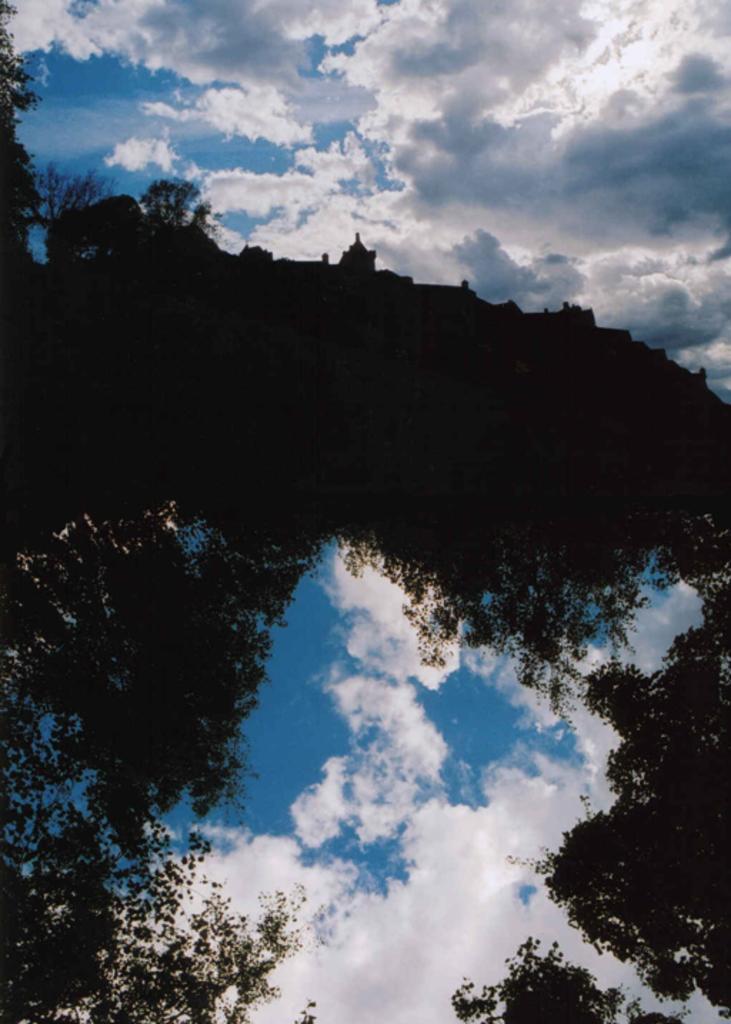Can you describe this image briefly? In this image, we can see some branches. There are clouds in the sky. 